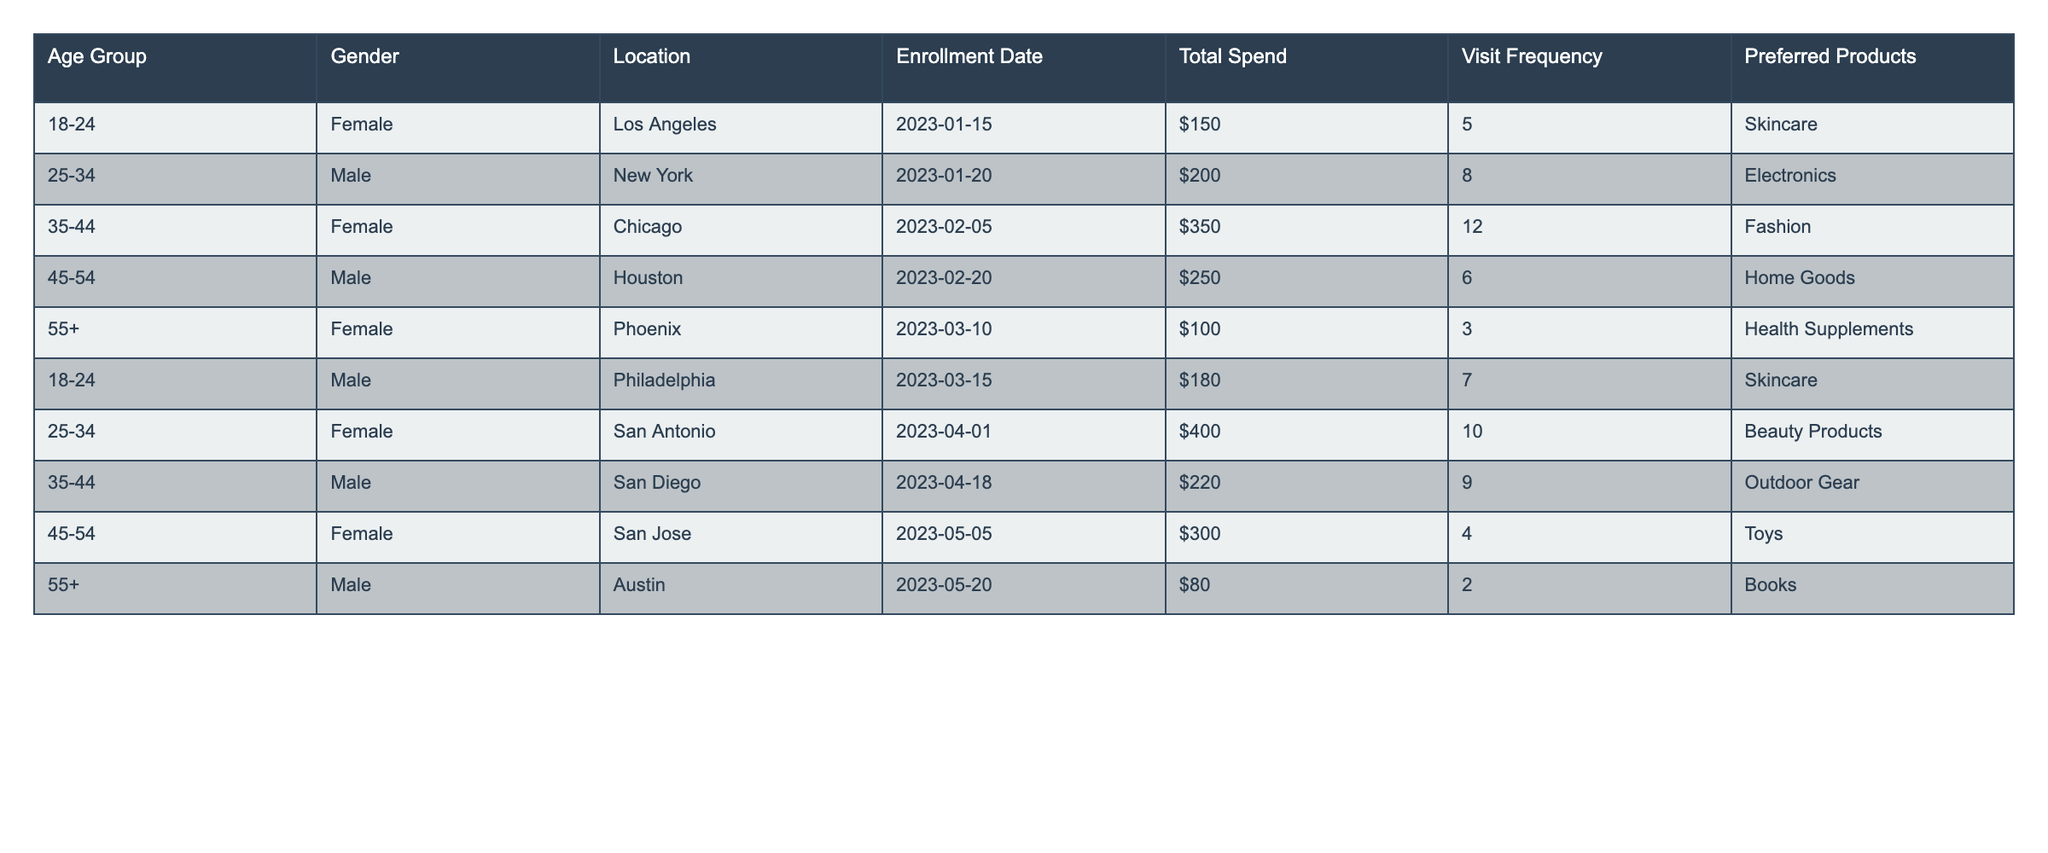What is the total spend for customers aged 18-24? To find this, look for all entries in the age group 18-24: the spends are $150 (Female) and $180 (Male). Adding these amounts gives $150 + $180 = $330.
Answer: $330 Which gender has a higher total spend in the table? Add up the total spend for each gender: Female: $150 + $350 + $400 + $300 = $1200; Male: $200 + $250 + $220 + $80 = $750. Since $1200 is greater than $750, Females have a higher total spend.
Answer: Female How many customers come from Los Angeles? There is one entry in the table for Los Angeles, which is a customer aged 18-24, Female.
Answer: 1 What is the average visit frequency for customers aged 25-34? The visit frequencies for the 25-34 age group are 8 (Male) and 10 (Female). Their average is (8 + 10) / 2 = 9.
Answer: 9 Is there a customer from Chicago in the 55+ age group? There is one customer from Chicago (aged 35-44) and none from the 55+ age group. Therefore, the statement is false.
Answer: No What is the total spend for all customers from San Antonio and San Diego? The total spend from San Antonio is $400 and from San Diego is $220. Adding these gives $400 + $220 = $620.
Answer: $620 Which preferred product has the highest number of customers? Count the unique preferred products: Skincare (2), Electronics (1), Fashion (1), Home Goods (1), Health Supplements (1), Beauty Products (1), Outdoor Gear (1), Toys (1), and Books (1). Skincare has the highest count with 2 customers.
Answer: Skincare Calculate the median total spend. The total spends in ascending order are $80, $100, $150, $180, $200, $220, $250, $300, $350, $400. There are 10 values, and the median is the average of the 5th and 6th values: (200 + 220) / 2 = $210.
Answer: $210 How many customers have enrolled after February 2023? The enrollment dates after February are March 10 (Female, Phoenix), March 15 (Male, Philadelphia), April 1 (Female, San Antonio), April 18 (Male, San Diego), May 5 (Female, San Jose), and May 20 (Male, Austin), totaling 6 customers.
Answer: 6 What percentage of customers prefer Skincare as their product? There are 9 customers total, with 2 preferring Skincare. The percentage is (2/9) * 100 = 22.22%.
Answer: 22.22% 